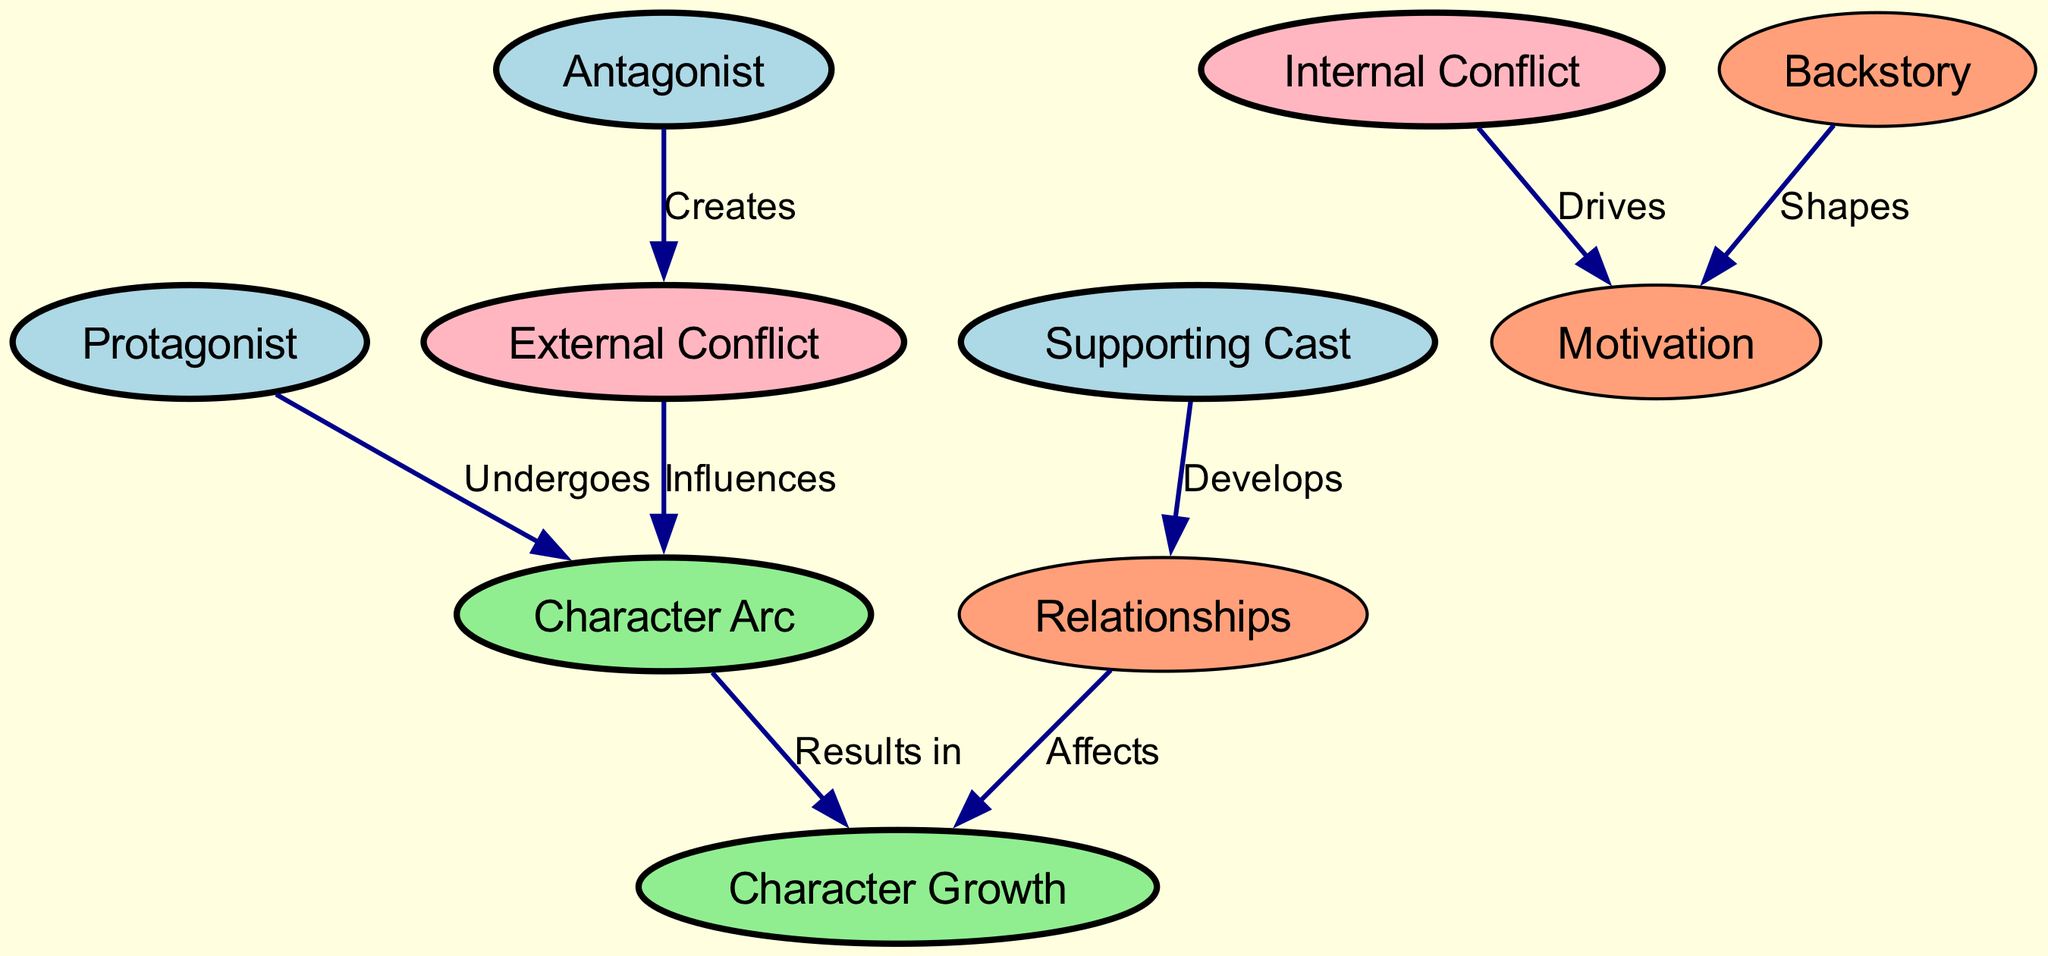What are the three main character types depicted in the diagram? The diagram includes nodes for "Protagonist", "Antagonist", and "Supporting Cast". These represent the three main character types in fantasy storytelling.
Answer: Protagonist, Antagonist, Supporting Cast How many relationships are represented in the edges of the diagram? The diagram shows a total of seven edges connecting various nodes, indicating the different relationships and influences among characters and their arcs.
Answer: 7 What shape represents "Character Arc" in the diagram? The "Character Arc" is displayed as an ellipse shape, consistent with the style used for key concepts that involve character development.
Answer: Ellipse Which character type undergoes a character arc? According to the diagram, the "Protagonist" is specifically noted to undergo a character arc.
Answer: Protagonist How does "Backstory" influence "Motivation"? The diagram indicates that "Backstory" shapes "Motivation", implying that a character's history contributes to their driving force in the story.
Answer: Shapes What type of conflict does the antagonist create? The edges indicate that the "Antagonist" creates "External Conflict", highlighting the source of opposition in the narrative.
Answer: External Conflict In what way do "Relationships" affect the protagonist’s journey? The diagram states that "Relationships" affect "Growth", suggesting that interpersonal connections contribute to the protagonist's development throughout the story.
Answer: Affects What drives "Internal Conflict"? The diagram shows that "Internal Conflict" is driven by "Motivation", indicating that a character's desires or goals can lead to inner struggles.
Answer: Drives Which aspect results from a character's arc according to the diagram? The diagram clearly points out that "Character Growth" results from the "Character Arc", illustrating the ultimate outcome of a character's journey.
Answer: Character Growth 